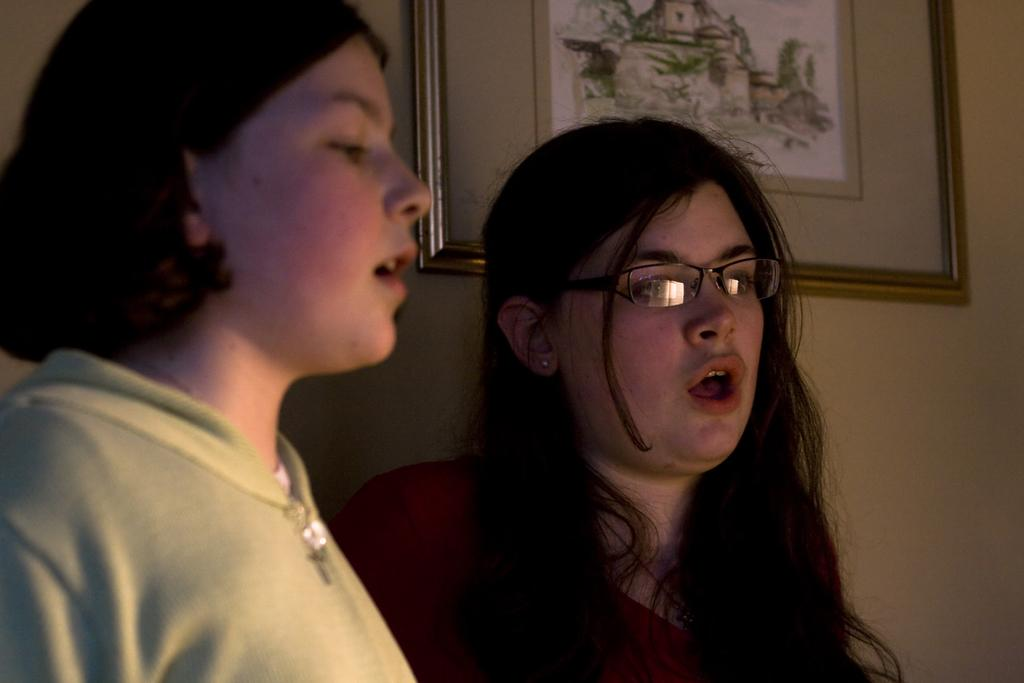How many people are in the image? There are two persons standing in the image. What is behind the persons in the image? There is a wall behind the persons. What can be seen on the wall? There is a frame on the wall. What idea did the police have for solving the case in the image? There is no mention of a case or police in the image, so it is not possible to answer that question. 